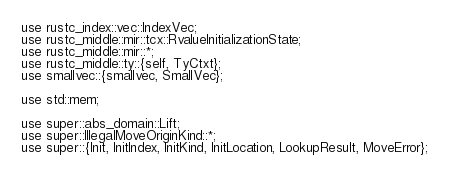Convert code to text. <code><loc_0><loc_0><loc_500><loc_500><_Rust_>use rustc_index::vec::IndexVec;
use rustc_middle::mir::tcx::RvalueInitializationState;
use rustc_middle::mir::*;
use rustc_middle::ty::{self, TyCtxt};
use smallvec::{smallvec, SmallVec};

use std::mem;

use super::abs_domain::Lift;
use super::IllegalMoveOriginKind::*;
use super::{Init, InitIndex, InitKind, InitLocation, LookupResult, MoveError};</code> 